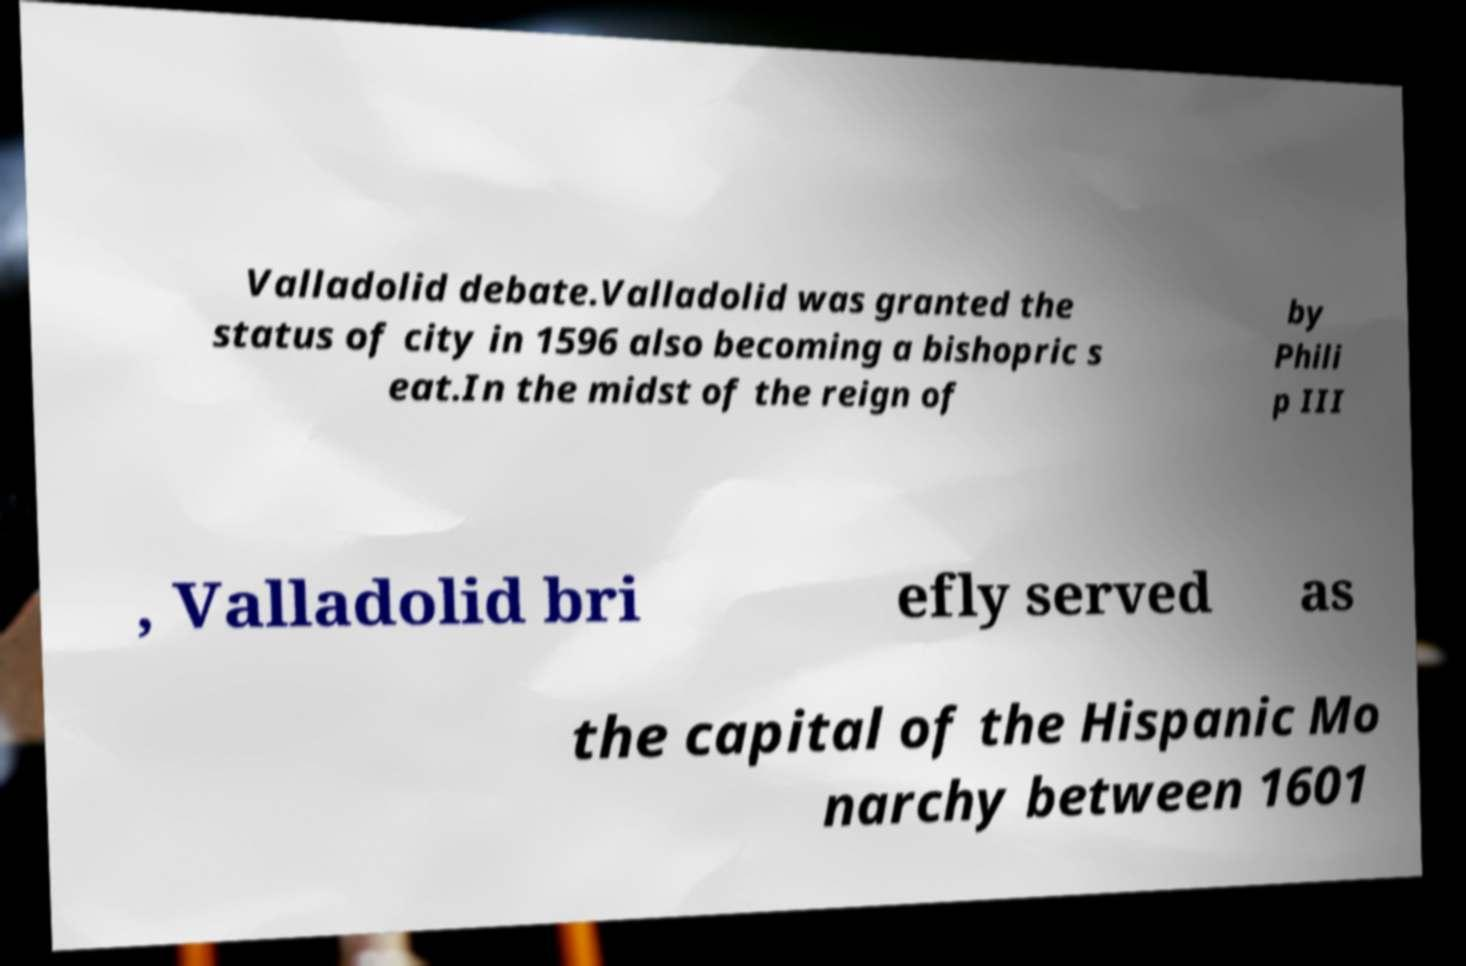Can you read and provide the text displayed in the image?This photo seems to have some interesting text. Can you extract and type it out for me? Valladolid debate.Valladolid was granted the status of city in 1596 also becoming a bishopric s eat.In the midst of the reign of by Phili p III , Valladolid bri efly served as the capital of the Hispanic Mo narchy between 1601 